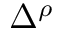<formula> <loc_0><loc_0><loc_500><loc_500>\Delta ^ { \rho }</formula> 